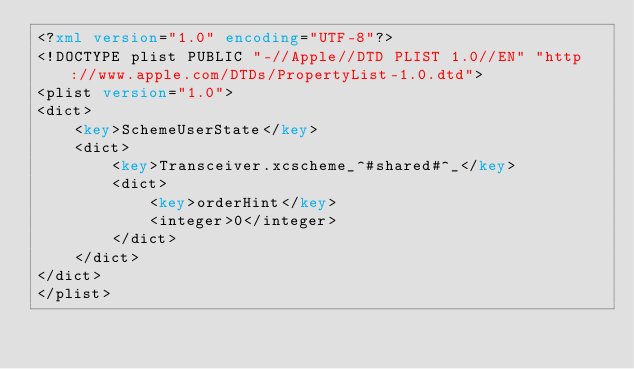<code> <loc_0><loc_0><loc_500><loc_500><_XML_><?xml version="1.0" encoding="UTF-8"?>
<!DOCTYPE plist PUBLIC "-//Apple//DTD PLIST 1.0//EN" "http://www.apple.com/DTDs/PropertyList-1.0.dtd">
<plist version="1.0">
<dict>
	<key>SchemeUserState</key>
	<dict>
		<key>Transceiver.xcscheme_^#shared#^_</key>
		<dict>
			<key>orderHint</key>
			<integer>0</integer>
		</dict>
	</dict>
</dict>
</plist>
</code> 